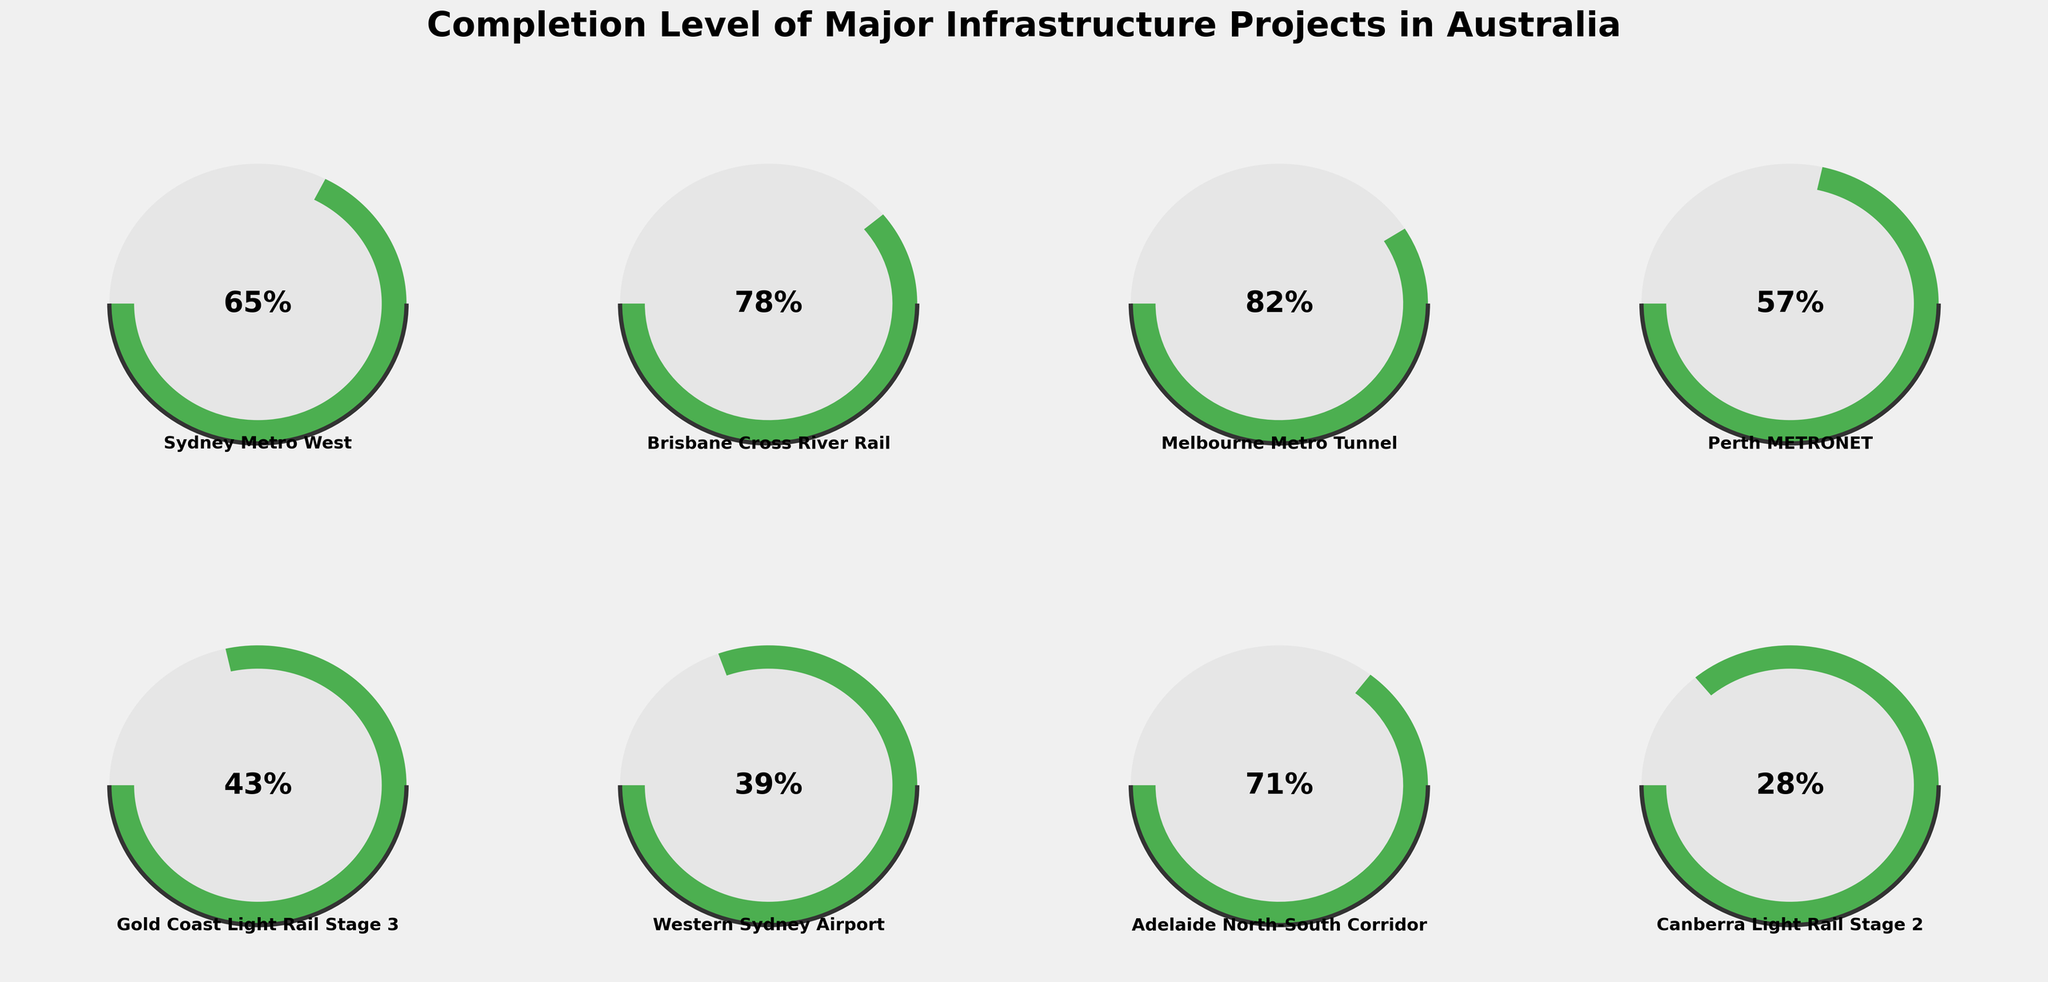Which project has the highest completion percentage? When observing the gauge meters, the project with the gauge needle moves furthest to the right has the highest completion. Melbourne Metro Tunnel shows a completion percentage of 82%, the highest among the projects listed.
Answer: Melbourne Metro Tunnel Which project is the least complete? By looking at the positions of the gauge needles, the longed-to-the-left needle indicates the least completion. Canberra Light Rail Stage 2 has a percentage of 28%, the lowest, making it the least complete project.
Answer: Canberra Light Rail Stage 2 What is the combined percentage completion of Brisbane Cross River Rail and Adelaide North-South Corridor? First, note the completion percentages of Brisbane Cross River Rail (78%) and Adelaide North-South Corridor (71%). Then, sum these two values: 78% + 71% = 149%.
Answer: 149% How many projects have a completion percentage of over 70%? Identify and count all projects with the gauge needles indicating over 70%. Melbourne Metro Tunnel (82%), Brisbane Cross River Rail (78%), and Adelaide North-South Corridor (71%) meet this criterion. That makes three projects total.
Answer: 3 Is Melbourne Metro Tunnel more complete than Perth METRONET? Compare the completion percentages directly: Melbourne Metro Tunnel has 82%, while Perth METRONET has 57%. Since 82% is greater than 57%, Melbourne Metro Tunnel is indeed more complete than Perth METRONET.
Answer: Yes What is the average completion percentage of all projects? Add all the completion percentages together then divide by the number of projects. Total is 65 + 78 + 82 + 57 + 43 + 39 + 71 + 28 = 463. Dividing by 8 projects gives 463 / 8 = 57.875%.
Answer: 57.875% Which project has a completion percentage close to the national average? Calculate the average completion percentage as 57.875%, then compare it to individual project percentages. Perth METRONET at 57% is closest to this average.
Answer: Perth METRONET How does the completion percentage of Western Sydney Airport compare to Gold Coast Light Rail Stage 3? Compare the two percentages directly: Western Sydney Airport has 39% completion, while Gold Coast Light Rail Stage 3 has 43%. Note that Gold Coast Light Rail Stage 3 is slightly higher in completion percentage.
Answer: Western Sydney Airport is lower What are the two projects with completion percentages between 40% and 60%? Identify projects whose gauge needles fall within the 40-60% range. The projects that meet this criterion are Perth METRONET (57%) and Gold Coast Light Rail Stage 3 (43%).
Answer: Perth METRONET, Gold Coast Light Rail Stage 3 